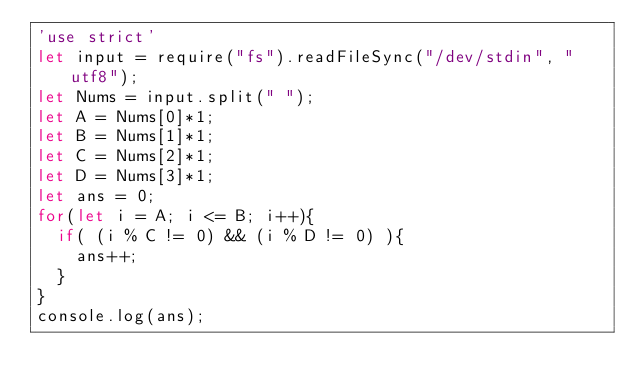Convert code to text. <code><loc_0><loc_0><loc_500><loc_500><_JavaScript_>'use strict'
let input = require("fs").readFileSync("/dev/stdin", "utf8");
let Nums = input.split(" ");
let A = Nums[0]*1;
let B = Nums[1]*1;
let C = Nums[2]*1;
let D = Nums[3]*1;
let ans = 0;
for(let i = A; i <= B; i++){
  if( (i % C != 0) && (i % D != 0) ){
    ans++;
  }
}
console.log(ans);</code> 